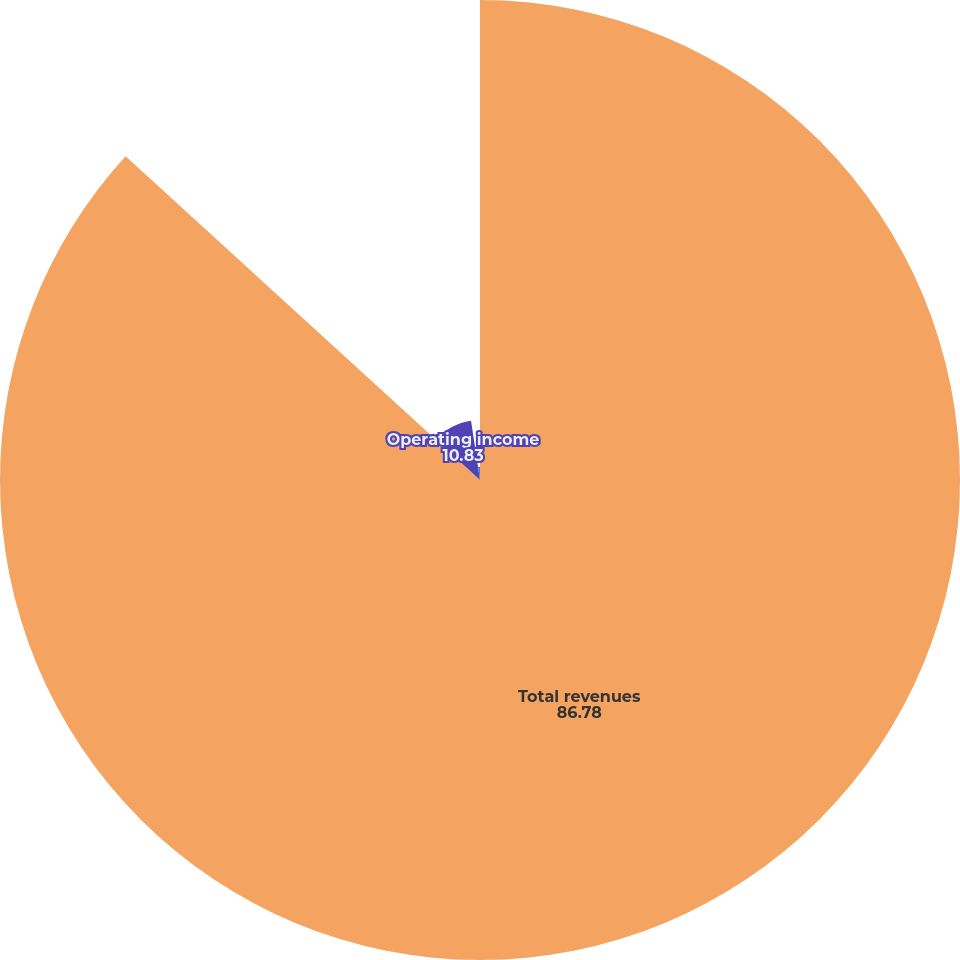Convert chart to OTSL. <chart><loc_0><loc_0><loc_500><loc_500><pie_chart><fcel>Total revenues<fcel>Operating income<fcel>Net income<nl><fcel>86.78%<fcel>10.83%<fcel>2.39%<nl></chart> 